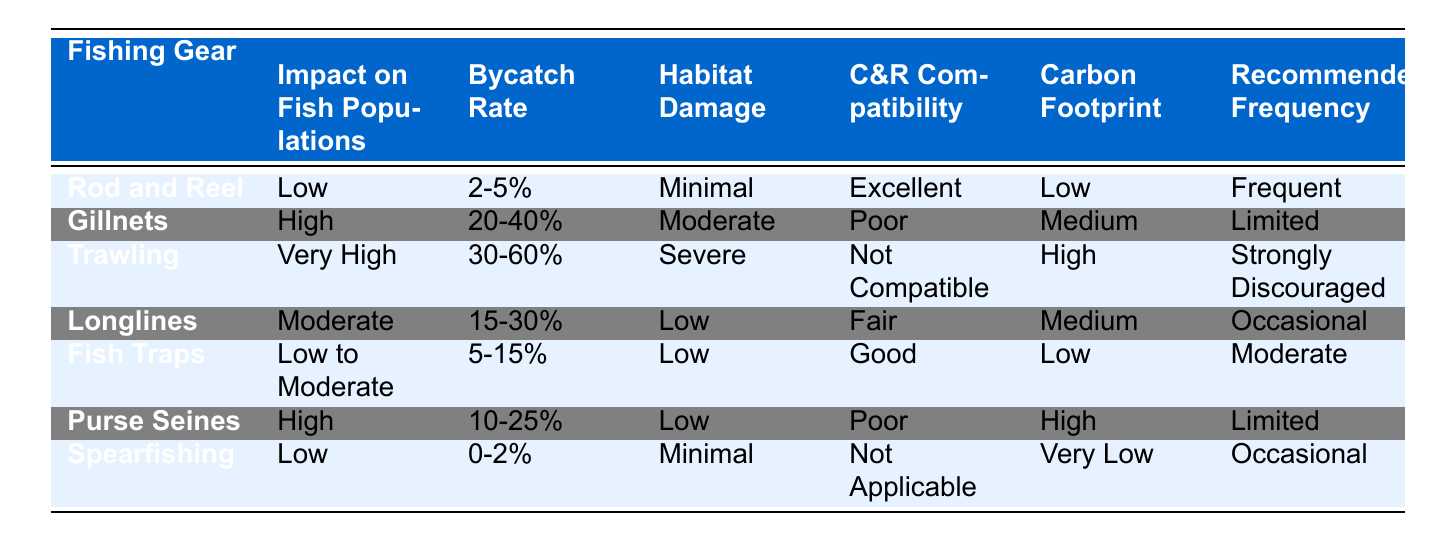What is the bycatch rate for Rod and Reel? According to the table, the bycatch rate for Rod and Reel is specifically stated as 2-5%.
Answer: 2-5% Which fishing gear has the highest carbon footprint? The table shows that Trawling has the highest carbon footprint, labeled as "High".
Answer: High Is Spearfishing compatible with Catch and Release (C&R)? The table indicates that Spearfishing has the designation "Not Applicable" for C&R compatibility.
Answer: Not Applicable What is the average bycatch rate for Gillnets and Purse Seines? Gillnets have a bycatch rate of 20-40% and Purse Seines have a rate of 10-25%. To find the average, we consider the midpoint of each range: (30% + 17.5%) / 2 = 23.75%.
Answer: 23.75% How many fishing gears have low habitat damage? From the table, Rod and Reel, Longlines, Fish Traps, and Spearfishing all have low or minimal habitat damage. Therefore, the total count is four.
Answer: 4 Is there any fishing gear listed that has high impact on fish populations and good C&R compatibility? The table shows Gillnets and Trawling have high impact on fish populations with poor C&R compatibility, while other gear does not meet both criteria simultaneously.
Answer: No What is the recommended frequency for using Fish Traps? The table states that Fish Traps have a recommended frequency of "Moderate".
Answer: Moderate Which fishing gear combines low bycatch rates and excellent C&R compatibility? According to the table, Rod and Reel has a low bycatch rate (2-5%) and excellent C&R compatibility.
Answer: Rod and Reel What is the total number of fishing gears with "High" impact on fish populations? The table indicates two fishing gears, Gillnets and Purse Seines, listed with "High" impact on fish populations.
Answer: 2 If you were to choose a fishing gear with minimal habitat damage and low carbon footprint, which would it be? The table shows that both Rod and Reel and Spearfishing have minimal habitat damage and either low or very low carbon footprints. Among these, Rod and Reel is a better option as it also has excellent C&R compatibility.
Answer: Rod and Reel 